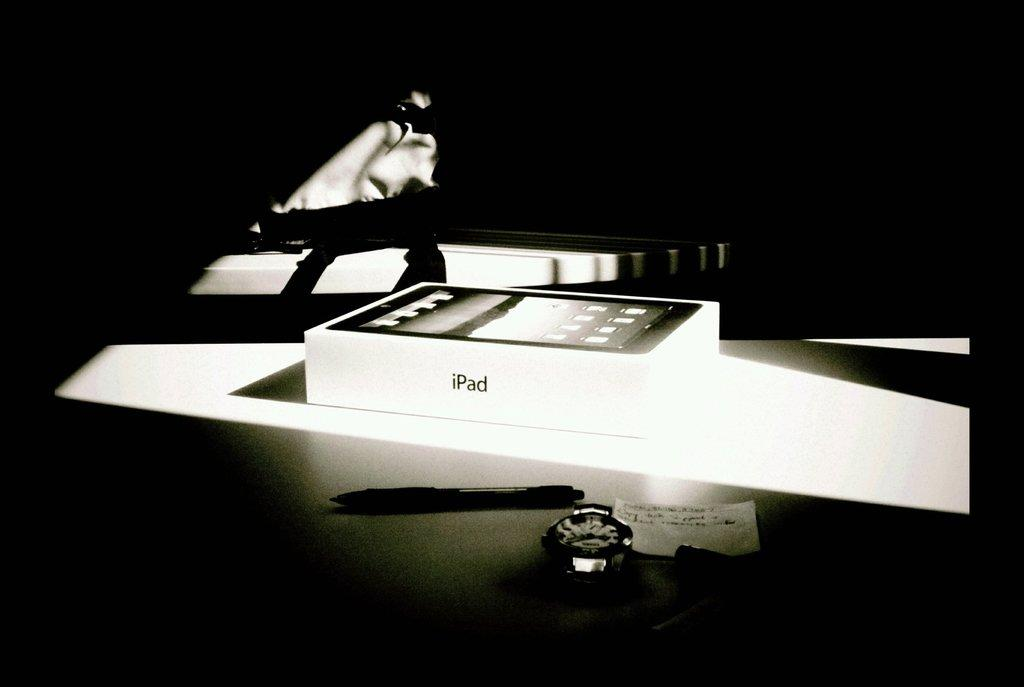<image>
Offer a succinct explanation of the picture presented. iPad box with sunlight beam on it with a pen and a watch face only in front of it in the shadows. 